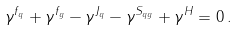Convert formula to latex. <formula><loc_0><loc_0><loc_500><loc_500>\gamma ^ { f _ { q } } + \gamma ^ { f _ { g } } - \gamma ^ { J _ { q } } - \gamma ^ { S _ { q g } } + \gamma ^ { H } = 0 \, .</formula> 